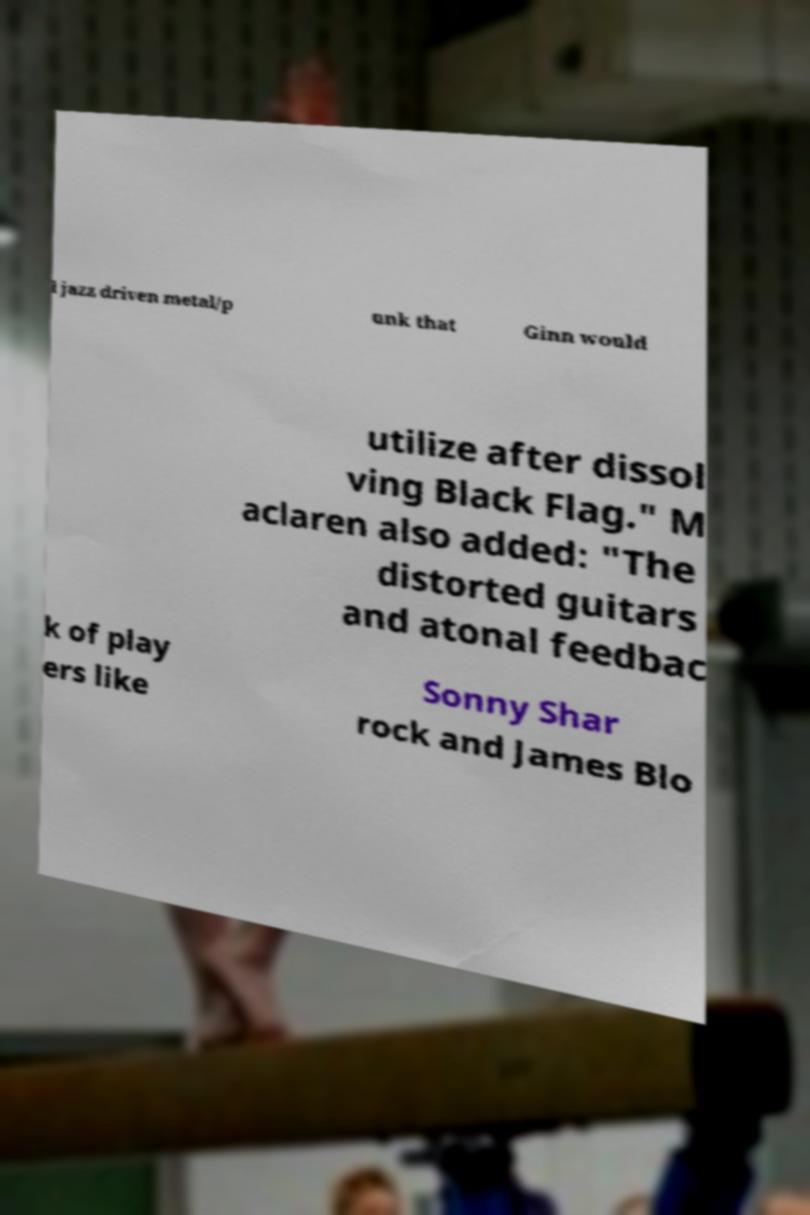Can you accurately transcribe the text from the provided image for me? l jazz driven metal/p unk that Ginn would utilize after dissol ving Black Flag." M aclaren also added: "The distorted guitars and atonal feedbac k of play ers like Sonny Shar rock and James Blo 